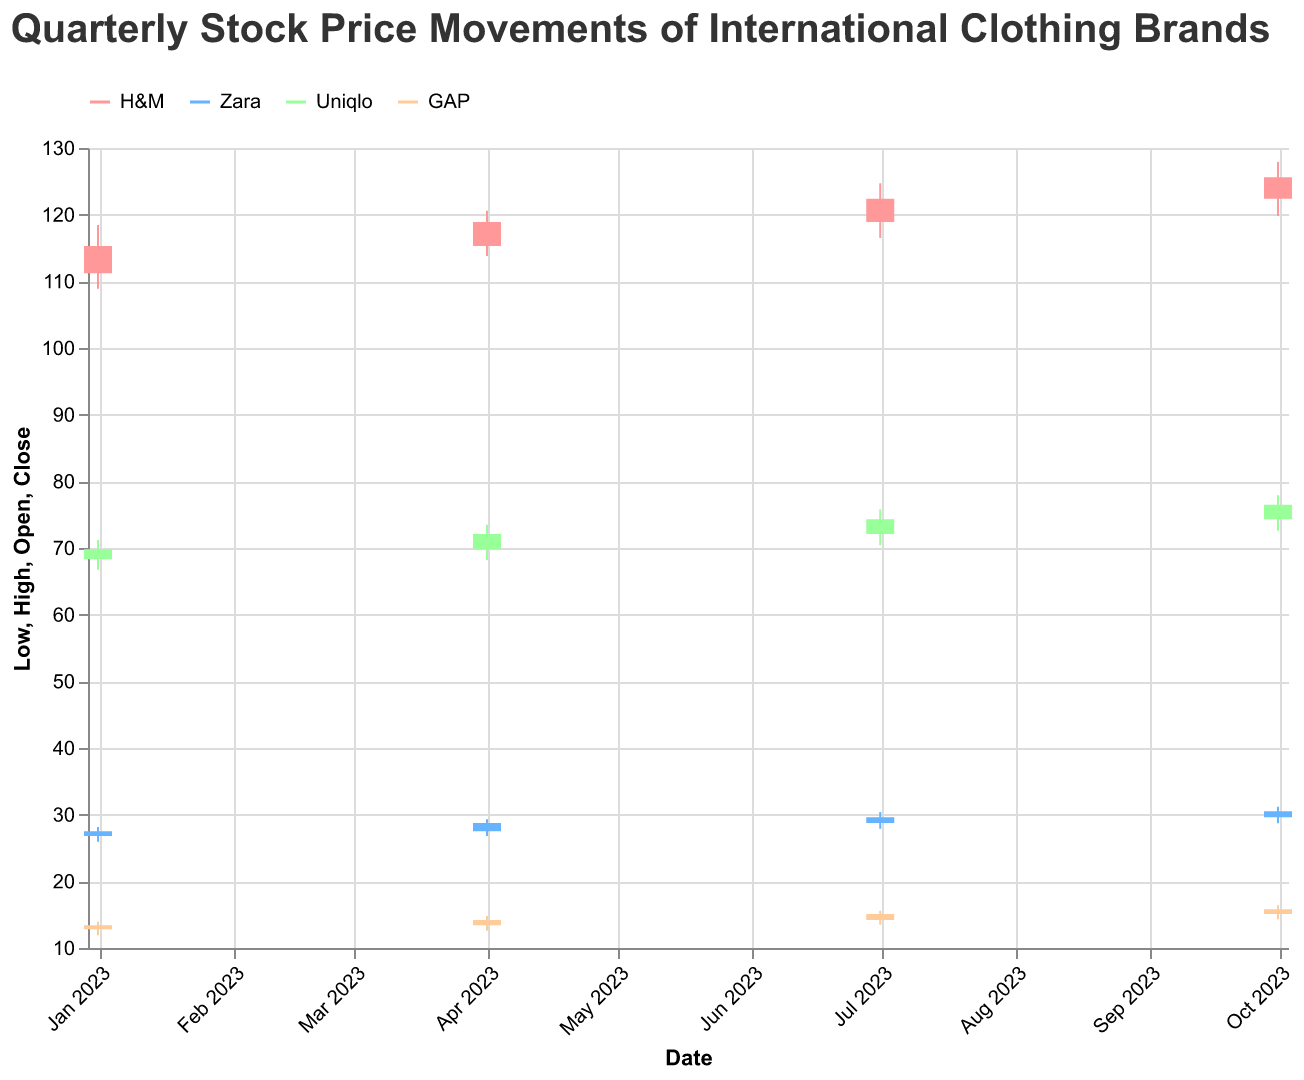What is the title of the figure? The title is usually prominently displayed at the top of the figure.
Answer: Quarterly Stock Price Movements of International Clothing Brands Which company had the highest closing price in the first quarter of 2023? Look at the closing price for each company in January 2023. Uniqlo has the highest closing price.
Answer: Uniqlo What is the overall trend in the stock prices of H&M throughout 2023? Check the opening and closing prices of H&M for each quarter from January to October 2023. The stock price generally increases from 111.20 to 125.60.
Answer: Increasing Between which quarters did Zara experience the highest quarterly high price change? Compare the high prices of Zara for each quarter and calculate the differences. The highest change is from Q2 to Q3 (29.30 to 31.20).
Answer: Q2 to Q3 What was the lowest stock price for GAP in any quarter of 2023? Look for the lowest low price of GAP across all quarters. The lowest is 11.90 in the first quarter.
Answer: 11.90 Compare the closing prices of Uniqlo for the first and last quarters of 2023. By how much did the price change? Subtract the closing price of Uniqlo in January from that in October. The change is 76.50 - 69.80 = 6.70.
Answer: 6.70 Which company saw the least volatility in terms of price range (high-low) over all quarters in 2023? Calculate the range (high - low) for each company per quarter and sum them up or average them. Zara appears to have the least overall volatility.
Answer: Zara How did the closing price of GAP compare to H&M in the second quarter of 2023? Compare the closing prices for GAP and H&M in April 2023. H&M had a closing price of 118.90, while GAP had 14.20, making H&M significantly higher.
Answer: H&M higher For which quarter did Uniqlo have the highest closing price? Look at the closing prices for Uniqlo in each quarter. The highest closing price is 76.50 in the fourth quarter.
Answer: Q4 What is the average closing price of Zara over all the quarters in 2023? Sum the closing prices of Zara for all quarters (27.50 + 28.75 + 29.60 + 30.50) = 116.35, then divide by 4. The average is 116.35 / 4 = 29.09.
Answer: 29.09 